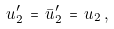<formula> <loc_0><loc_0><loc_500><loc_500>u _ { 2 } ^ { \prime } \, = \, \bar { u } _ { 2 } ^ { \prime } \, = \, u _ { 2 } \, ,</formula> 